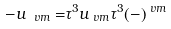<formula> <loc_0><loc_0><loc_500><loc_500>- u _ { \ v m } = & \tau ^ { 3 } u _ { \ v m } \tau ^ { 3 } ( - ) ^ { \ v m }</formula> 